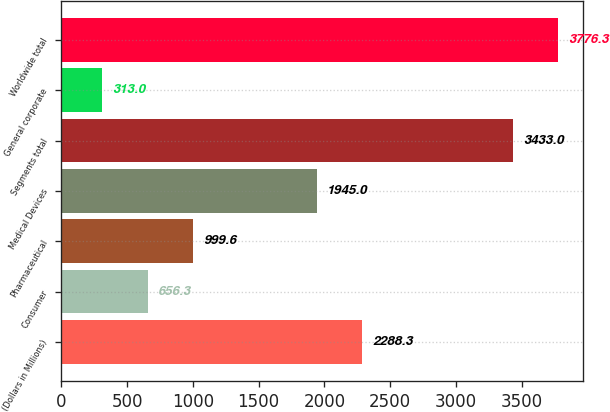Convert chart. <chart><loc_0><loc_0><loc_500><loc_500><bar_chart><fcel>(Dollars in Millions)<fcel>Consumer<fcel>Pharmaceutical<fcel>Medical Devices<fcel>Segments total<fcel>General corporate<fcel>Worldwide total<nl><fcel>2288.3<fcel>656.3<fcel>999.6<fcel>1945<fcel>3433<fcel>313<fcel>3776.3<nl></chart> 